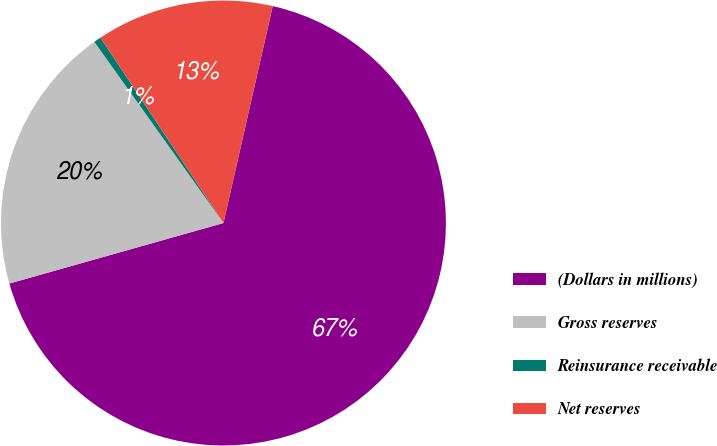Convert chart to OTSL. <chart><loc_0><loc_0><loc_500><loc_500><pie_chart><fcel>(Dollars in millions)<fcel>Gross reserves<fcel>Reinsurance receivable<fcel>Net reserves<nl><fcel>67.06%<fcel>19.53%<fcel>0.53%<fcel>12.88%<nl></chart> 